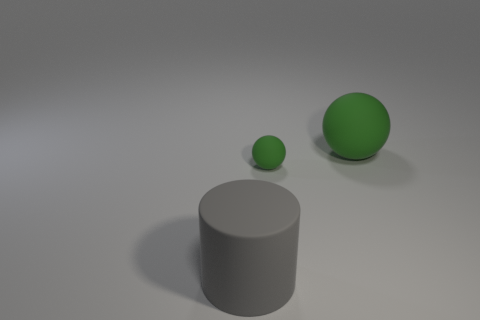Add 3 purple matte spheres. How many objects exist? 6 Subtract all cylinders. How many objects are left? 2 Add 3 big green matte things. How many big green matte things exist? 4 Subtract 1 gray cylinders. How many objects are left? 2 Subtract all large brown matte spheres. Subtract all green spheres. How many objects are left? 1 Add 1 big gray objects. How many big gray objects are left? 2 